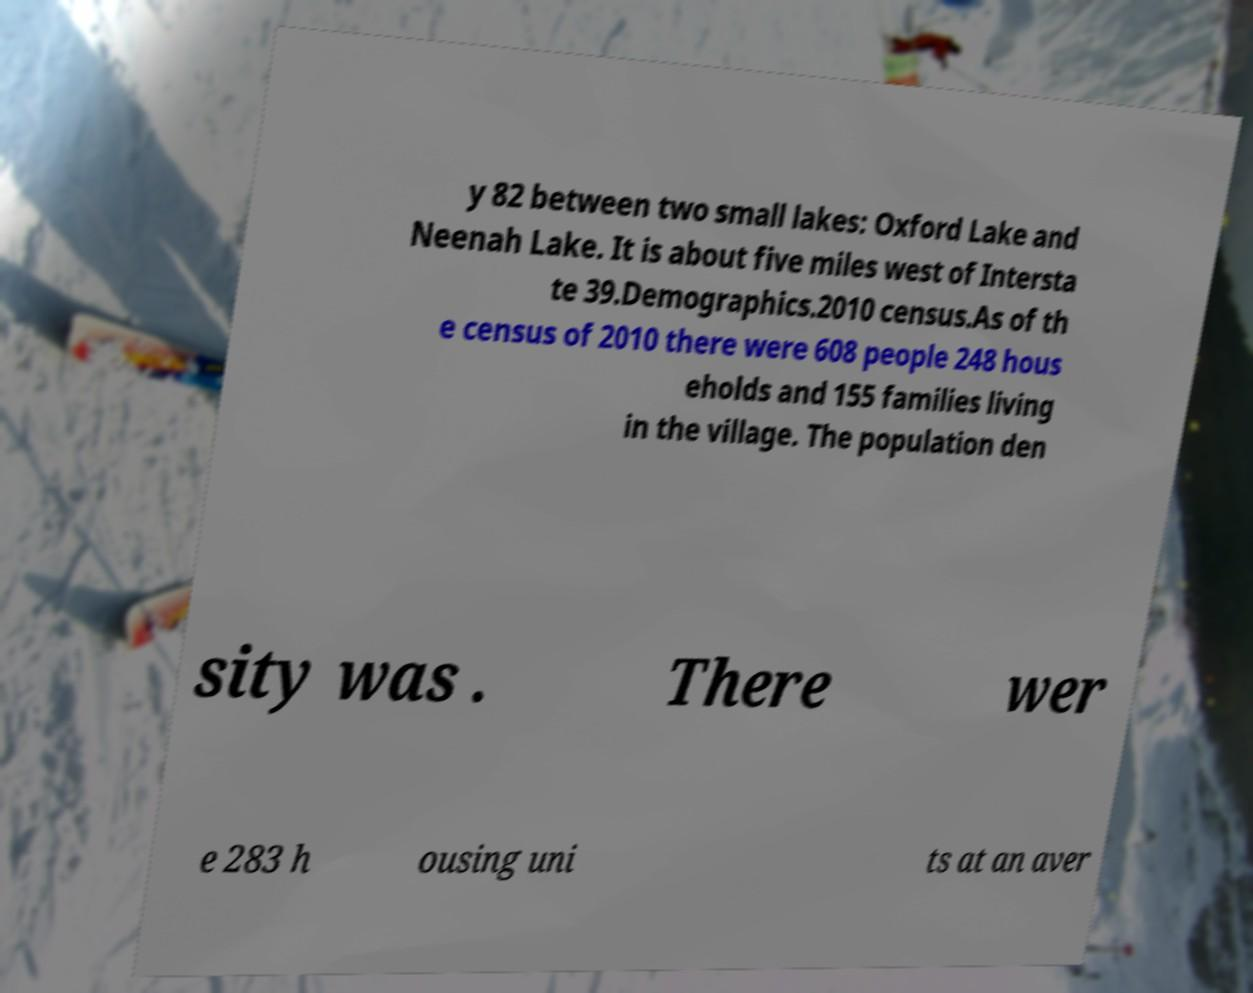Could you assist in decoding the text presented in this image and type it out clearly? y 82 between two small lakes: Oxford Lake and Neenah Lake. It is about five miles west of Intersta te 39.Demographics.2010 census.As of th e census of 2010 there were 608 people 248 hous eholds and 155 families living in the village. The population den sity was . There wer e 283 h ousing uni ts at an aver 